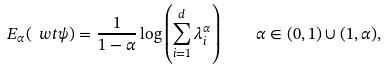<formula> <loc_0><loc_0><loc_500><loc_500>E _ { \alpha } ( \ w t { \psi } ) = \frac { 1 } { 1 - \alpha } \log \left ( \sum _ { i = 1 } ^ { d } \lambda _ { i } ^ { \alpha } \right ) \quad \alpha \in ( 0 , 1 ) \cup ( 1 , \alpha ) ,</formula> 